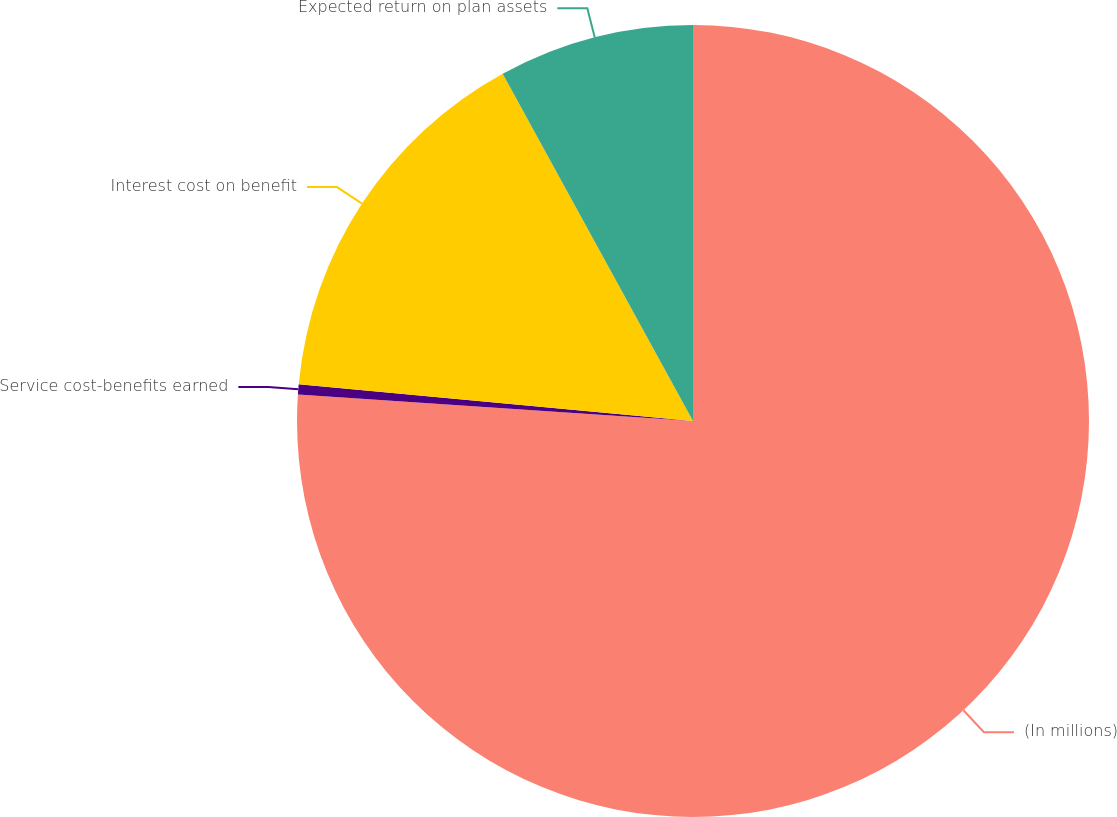<chart> <loc_0><loc_0><loc_500><loc_500><pie_chart><fcel>(In millions)<fcel>Service cost-benefits earned<fcel>Interest cost on benefit<fcel>Expected return on plan assets<nl><fcel>76.07%<fcel>0.41%<fcel>15.54%<fcel>7.98%<nl></chart> 